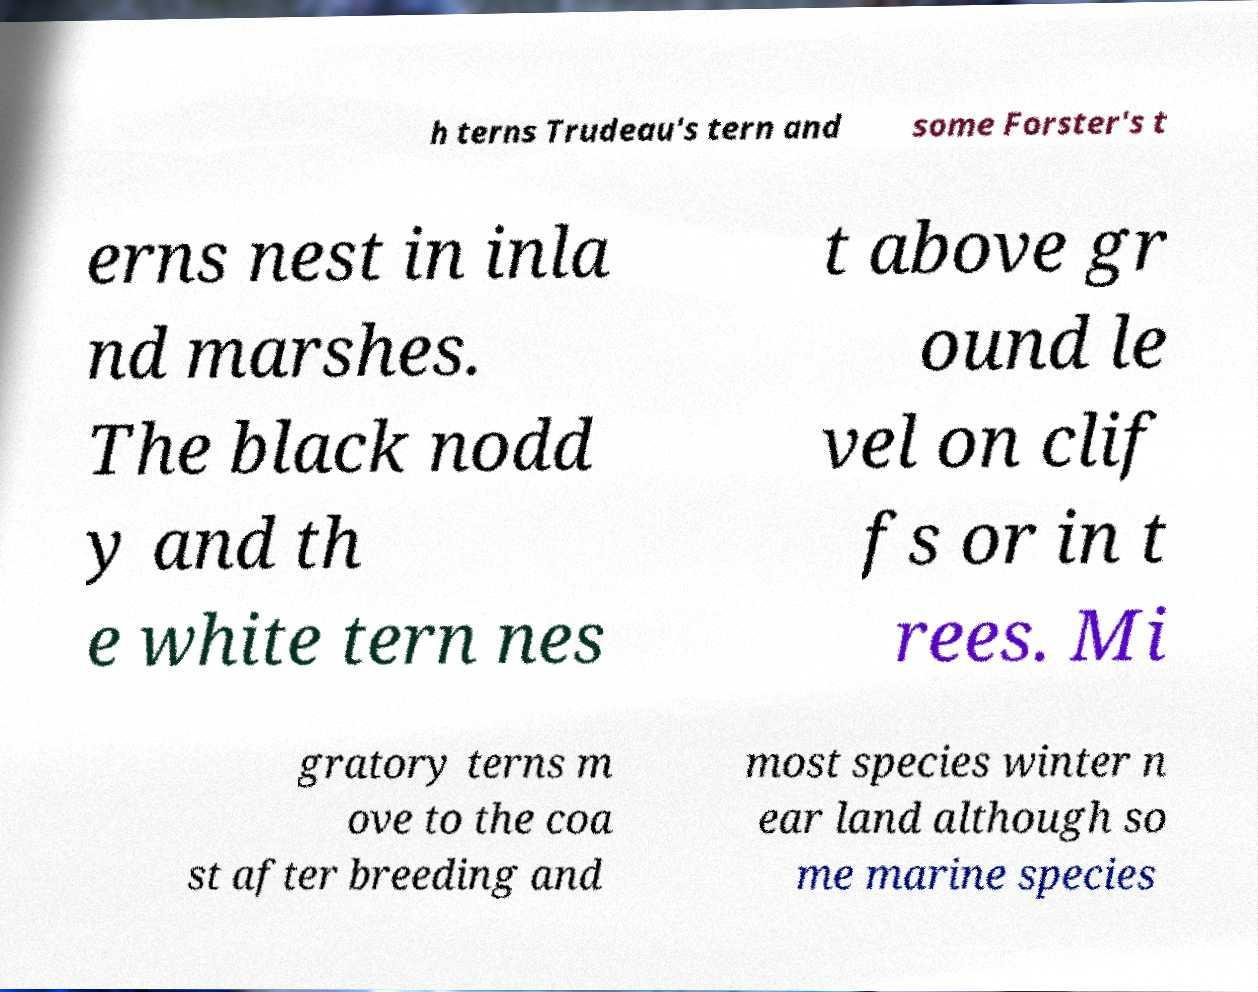Can you accurately transcribe the text from the provided image for me? h terns Trudeau's tern and some Forster's t erns nest in inla nd marshes. The black nodd y and th e white tern nes t above gr ound le vel on clif fs or in t rees. Mi gratory terns m ove to the coa st after breeding and most species winter n ear land although so me marine species 